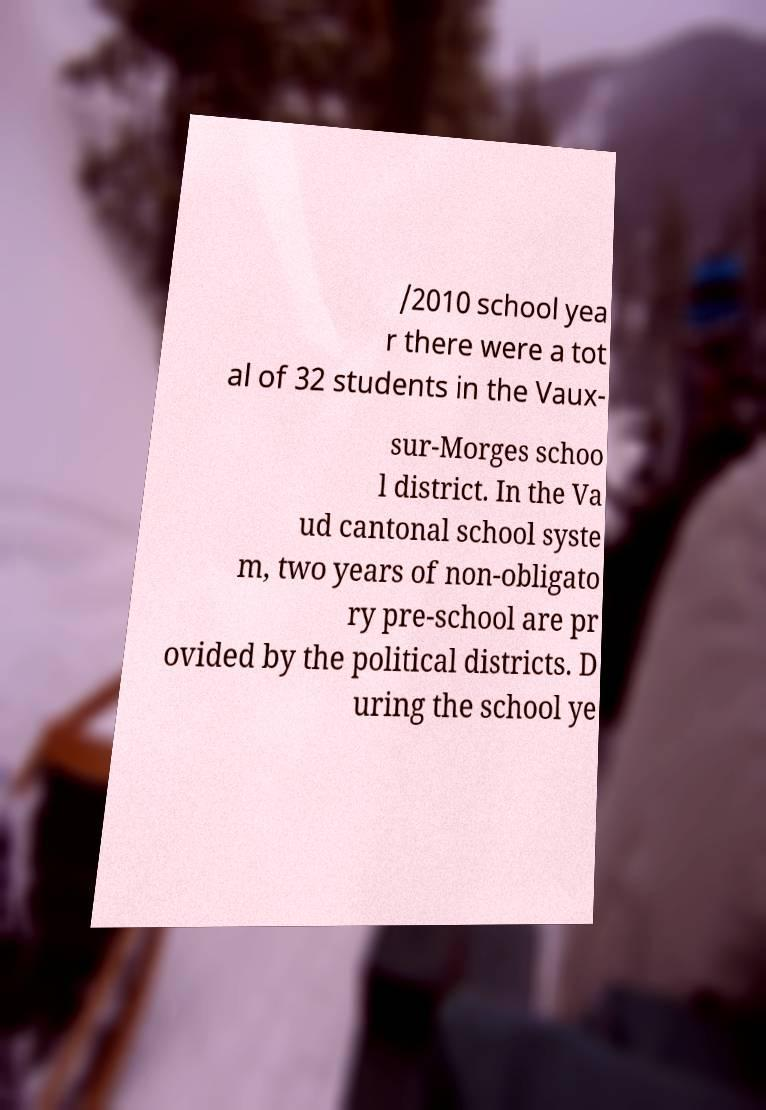There's text embedded in this image that I need extracted. Can you transcribe it verbatim? /2010 school yea r there were a tot al of 32 students in the Vaux- sur-Morges schoo l district. In the Va ud cantonal school syste m, two years of non-obligato ry pre-school are pr ovided by the political districts. D uring the school ye 